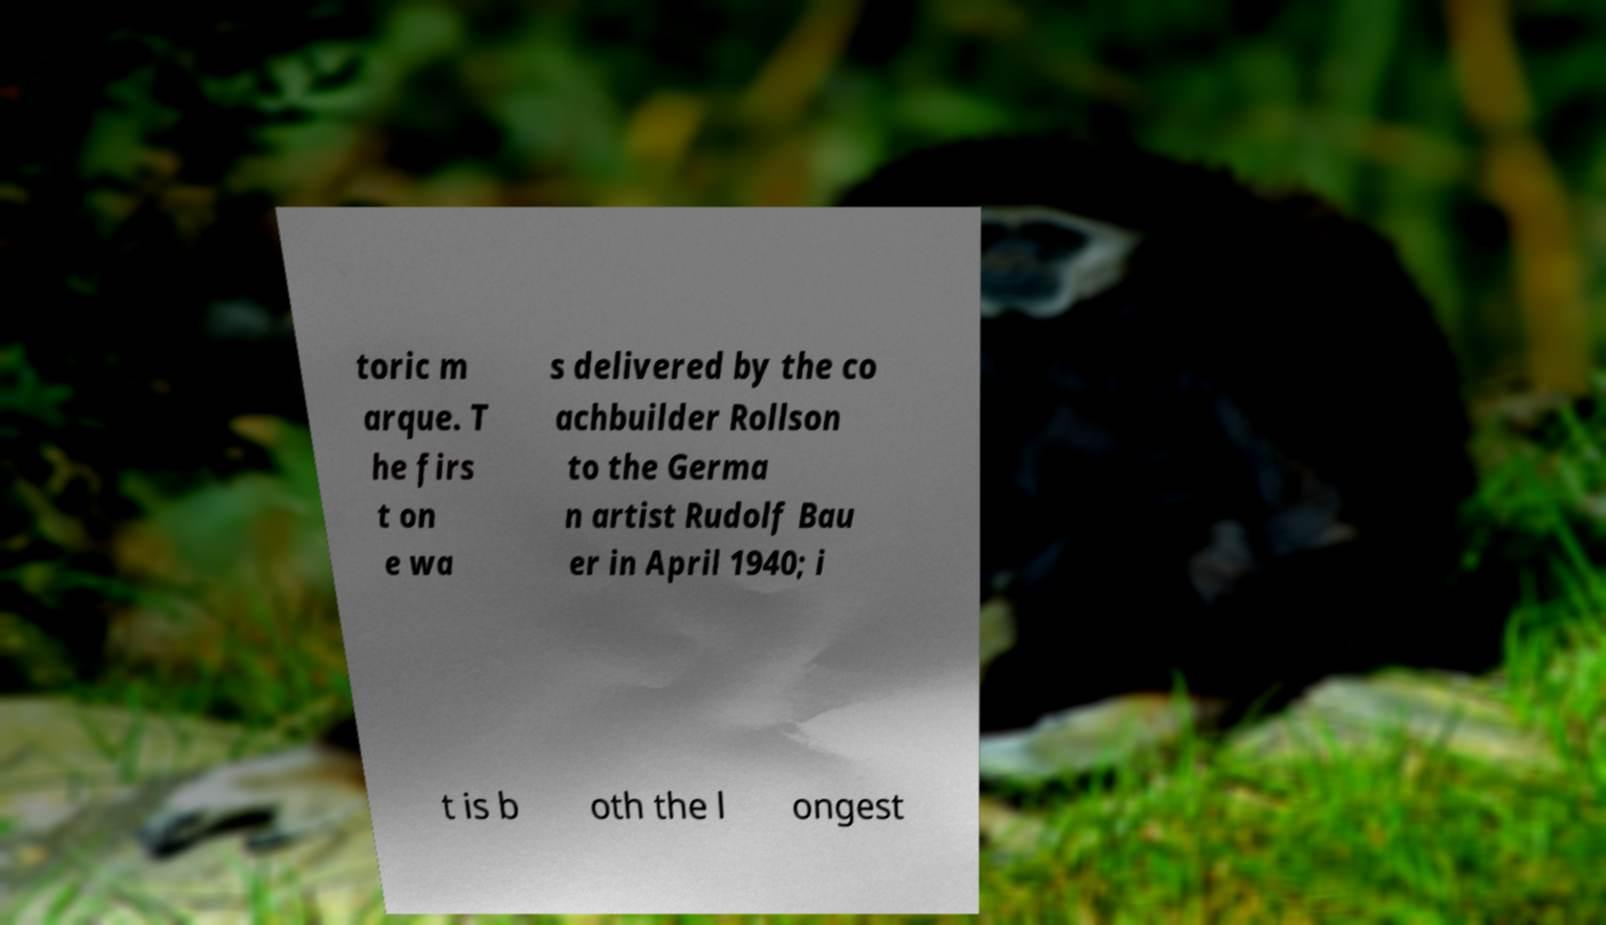What messages or text are displayed in this image? I need them in a readable, typed format. toric m arque. T he firs t on e wa s delivered by the co achbuilder Rollson to the Germa n artist Rudolf Bau er in April 1940; i t is b oth the l ongest 